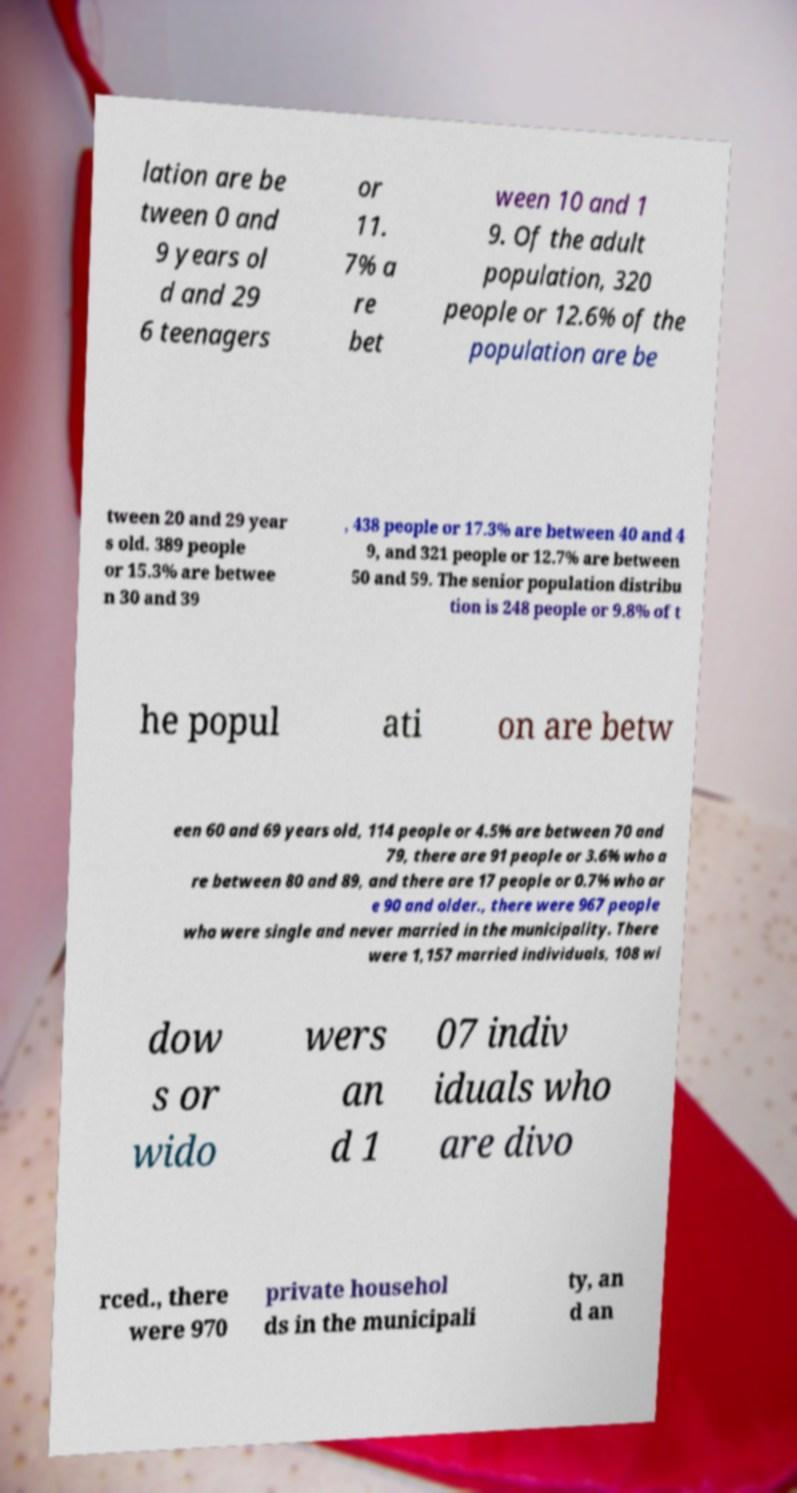Please identify and transcribe the text found in this image. lation are be tween 0 and 9 years ol d and 29 6 teenagers or 11. 7% a re bet ween 10 and 1 9. Of the adult population, 320 people or 12.6% of the population are be tween 20 and 29 year s old. 389 people or 15.3% are betwee n 30 and 39 , 438 people or 17.3% are between 40 and 4 9, and 321 people or 12.7% are between 50 and 59. The senior population distribu tion is 248 people or 9.8% of t he popul ati on are betw een 60 and 69 years old, 114 people or 4.5% are between 70 and 79, there are 91 people or 3.6% who a re between 80 and 89, and there are 17 people or 0.7% who ar e 90 and older., there were 967 people who were single and never married in the municipality. There were 1,157 married individuals, 108 wi dow s or wido wers an d 1 07 indiv iduals who are divo rced., there were 970 private househol ds in the municipali ty, an d an 